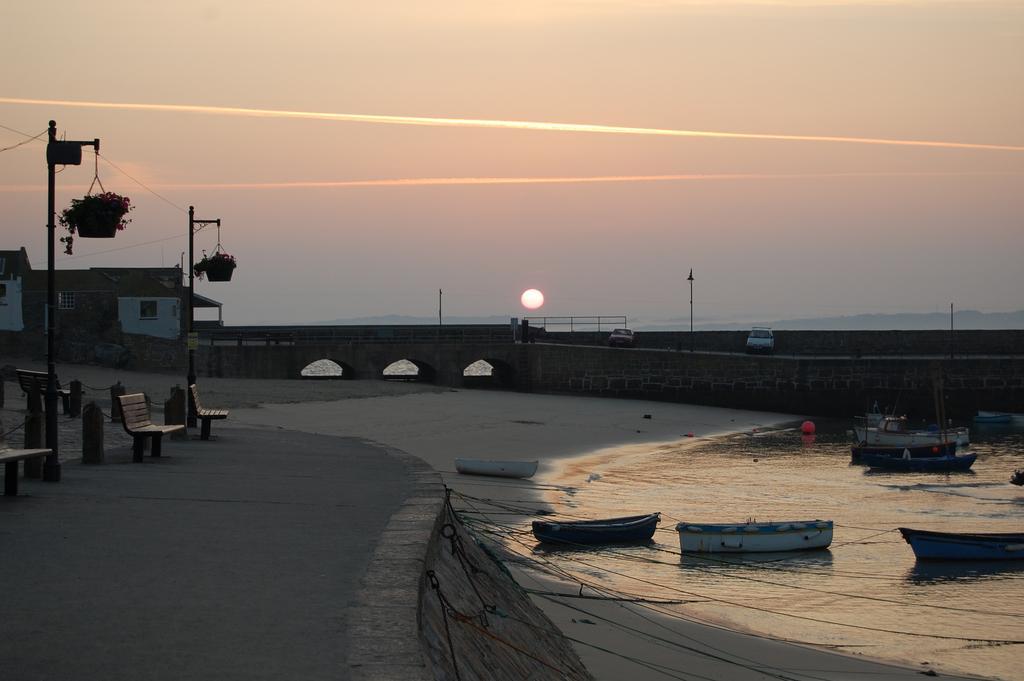In one or two sentences, can you explain what this image depicts? In this image I see the path and I see few boats over here and I see the water and I see few benches over here and I see the poles and I see 2 cars over here and I see a building over here and I see the sky in the background and I see the sun over here. 